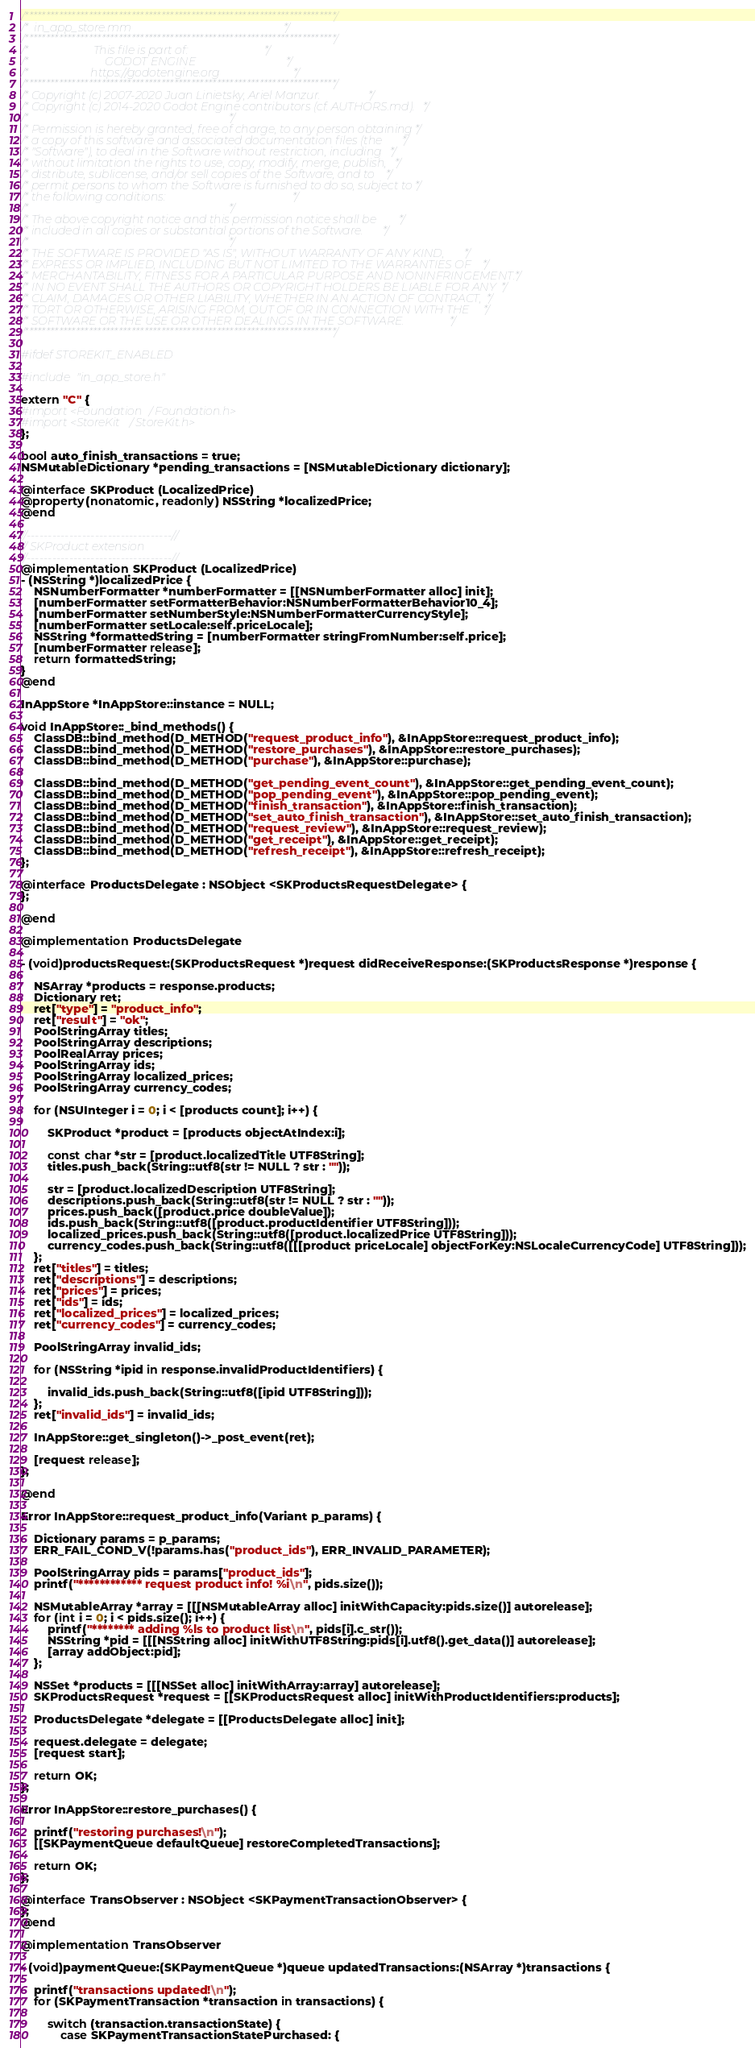Convert code to text. <code><loc_0><loc_0><loc_500><loc_500><_ObjectiveC_>/*************************************************************************/
/*  in_app_store.mm                                                      */
/*************************************************************************/
/*                       This file is part of:                           */
/*                           GODOT ENGINE                                */
/*                      https://godotengine.org                          */
/*************************************************************************/
/* Copyright (c) 2007-2020 Juan Linietsky, Ariel Manzur.                 */
/* Copyright (c) 2014-2020 Godot Engine contributors (cf. AUTHORS.md).   */
/*                                                                       */
/* Permission is hereby granted, free of charge, to any person obtaining */
/* a copy of this software and associated documentation files (the       */
/* "Software"), to deal in the Software without restriction, including   */
/* without limitation the rights to use, copy, modify, merge, publish,   */
/* distribute, sublicense, and/or sell copies of the Software, and to    */
/* permit persons to whom the Software is furnished to do so, subject to */
/* the following conditions:                                             */
/*                                                                       */
/* The above copyright notice and this permission notice shall be        */
/* included in all copies or substantial portions of the Software.       */
/*                                                                       */
/* THE SOFTWARE IS PROVIDED "AS IS", WITHOUT WARRANTY OF ANY KIND,       */
/* EXPRESS OR IMPLIED, INCLUDING BUT NOT LIMITED TO THE WARRANTIES OF    */
/* MERCHANTABILITY, FITNESS FOR A PARTICULAR PURPOSE AND NONINFRINGEMENT.*/
/* IN NO EVENT SHALL THE AUTHORS OR COPYRIGHT HOLDERS BE LIABLE FOR ANY  */
/* CLAIM, DAMAGES OR OTHER LIABILITY, WHETHER IN AN ACTION OF CONTRACT,  */
/* TORT OR OTHERWISE, ARISING FROM, OUT OF OR IN CONNECTION WITH THE     */
/* SOFTWARE OR THE USE OR OTHER DEALINGS IN THE SOFTWARE.                */
/*************************************************************************/

#ifdef STOREKIT_ENABLED

#include "in_app_store.h"

extern "C" {
#import <Foundation/Foundation.h>
#import <StoreKit/StoreKit.h>
};

bool auto_finish_transactions = true;
NSMutableDictionary *pending_transactions = [NSMutableDictionary dictionary];

@interface SKProduct (LocalizedPrice)
@property(nonatomic, readonly) NSString *localizedPrice;
@end

//----------------------------------//
// SKProduct extension
//----------------------------------//
@implementation SKProduct (LocalizedPrice)
- (NSString *)localizedPrice {
	NSNumberFormatter *numberFormatter = [[NSNumberFormatter alloc] init];
	[numberFormatter setFormatterBehavior:NSNumberFormatterBehavior10_4];
	[numberFormatter setNumberStyle:NSNumberFormatterCurrencyStyle];
	[numberFormatter setLocale:self.priceLocale];
	NSString *formattedString = [numberFormatter stringFromNumber:self.price];
	[numberFormatter release];
	return formattedString;
}
@end

InAppStore *InAppStore::instance = NULL;

void InAppStore::_bind_methods() {
	ClassDB::bind_method(D_METHOD("request_product_info"), &InAppStore::request_product_info);
	ClassDB::bind_method(D_METHOD("restore_purchases"), &InAppStore::restore_purchases);
	ClassDB::bind_method(D_METHOD("purchase"), &InAppStore::purchase);

	ClassDB::bind_method(D_METHOD("get_pending_event_count"), &InAppStore::get_pending_event_count);
	ClassDB::bind_method(D_METHOD("pop_pending_event"), &InAppStore::pop_pending_event);
	ClassDB::bind_method(D_METHOD("finish_transaction"), &InAppStore::finish_transaction);
	ClassDB::bind_method(D_METHOD("set_auto_finish_transaction"), &InAppStore::set_auto_finish_transaction);
	ClassDB::bind_method(D_METHOD("request_review"), &InAppStore::request_review);
	ClassDB::bind_method(D_METHOD("get_receipt"), &InAppStore::get_receipt);
	ClassDB::bind_method(D_METHOD("refresh_receipt"), &InAppStore::refresh_receipt);
};

@interface ProductsDelegate : NSObject <SKProductsRequestDelegate> {
};

@end

@implementation ProductsDelegate

- (void)productsRequest:(SKProductsRequest *)request didReceiveResponse:(SKProductsResponse *)response {

	NSArray *products = response.products;
	Dictionary ret;
	ret["type"] = "product_info";
	ret["result"] = "ok";
	PoolStringArray titles;
	PoolStringArray descriptions;
	PoolRealArray prices;
	PoolStringArray ids;
	PoolStringArray localized_prices;
	PoolStringArray currency_codes;

	for (NSUInteger i = 0; i < [products count]; i++) {

		SKProduct *product = [products objectAtIndex:i];

		const char *str = [product.localizedTitle UTF8String];
		titles.push_back(String::utf8(str != NULL ? str : ""));

		str = [product.localizedDescription UTF8String];
		descriptions.push_back(String::utf8(str != NULL ? str : ""));
		prices.push_back([product.price doubleValue]);
		ids.push_back(String::utf8([product.productIdentifier UTF8String]));
		localized_prices.push_back(String::utf8([product.localizedPrice UTF8String]));
		currency_codes.push_back(String::utf8([[[product priceLocale] objectForKey:NSLocaleCurrencyCode] UTF8String]));
	};
	ret["titles"] = titles;
	ret["descriptions"] = descriptions;
	ret["prices"] = prices;
	ret["ids"] = ids;
	ret["localized_prices"] = localized_prices;
	ret["currency_codes"] = currency_codes;

	PoolStringArray invalid_ids;

	for (NSString *ipid in response.invalidProductIdentifiers) {

		invalid_ids.push_back(String::utf8([ipid UTF8String]));
	};
	ret["invalid_ids"] = invalid_ids;

	InAppStore::get_singleton()->_post_event(ret);

	[request release];
};

@end

Error InAppStore::request_product_info(Variant p_params) {

	Dictionary params = p_params;
	ERR_FAIL_COND_V(!params.has("product_ids"), ERR_INVALID_PARAMETER);

	PoolStringArray pids = params["product_ids"];
	printf("************ request product info! %i\n", pids.size());

	NSMutableArray *array = [[[NSMutableArray alloc] initWithCapacity:pids.size()] autorelease];
	for (int i = 0; i < pids.size(); i++) {
		printf("******** adding %ls to product list\n", pids[i].c_str());
		NSString *pid = [[[NSString alloc] initWithUTF8String:pids[i].utf8().get_data()] autorelease];
		[array addObject:pid];
	};

	NSSet *products = [[[NSSet alloc] initWithArray:array] autorelease];
	SKProductsRequest *request = [[SKProductsRequest alloc] initWithProductIdentifiers:products];

	ProductsDelegate *delegate = [[ProductsDelegate alloc] init];

	request.delegate = delegate;
	[request start];

	return OK;
};

Error InAppStore::restore_purchases() {

	printf("restoring purchases!\n");
	[[SKPaymentQueue defaultQueue] restoreCompletedTransactions];

	return OK;
};

@interface TransObserver : NSObject <SKPaymentTransactionObserver> {
};
@end

@implementation TransObserver

- (void)paymentQueue:(SKPaymentQueue *)queue updatedTransactions:(NSArray *)transactions {

	printf("transactions updated!\n");
	for (SKPaymentTransaction *transaction in transactions) {

		switch (transaction.transactionState) {
			case SKPaymentTransactionStatePurchased: {</code> 